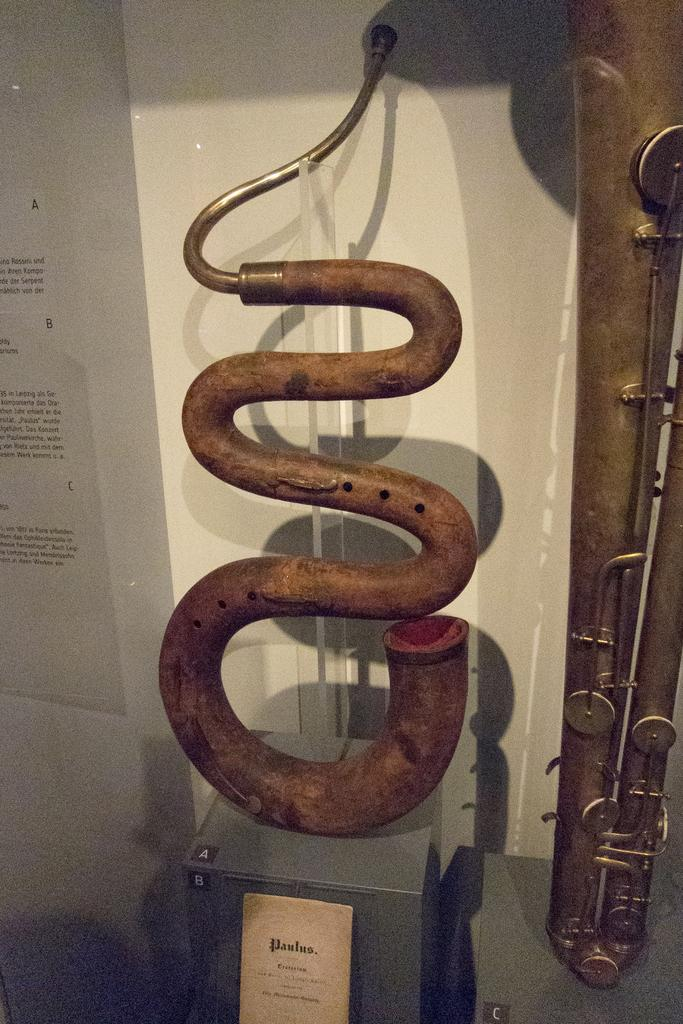What objects in the image are related to music? There are two musical instruments in the image. What is the color of the musical instruments? The musical instruments are brown in color. What is the white object in the image used for? There is a white color name board in the image, which is likely used for labeling or displaying information. What can be seen in the background of the image? There is a wall in the background of the image. How many giants are visible in the image? There are no giants present in the image. What type of rice is being served in the image? There is no rice present in the image. 